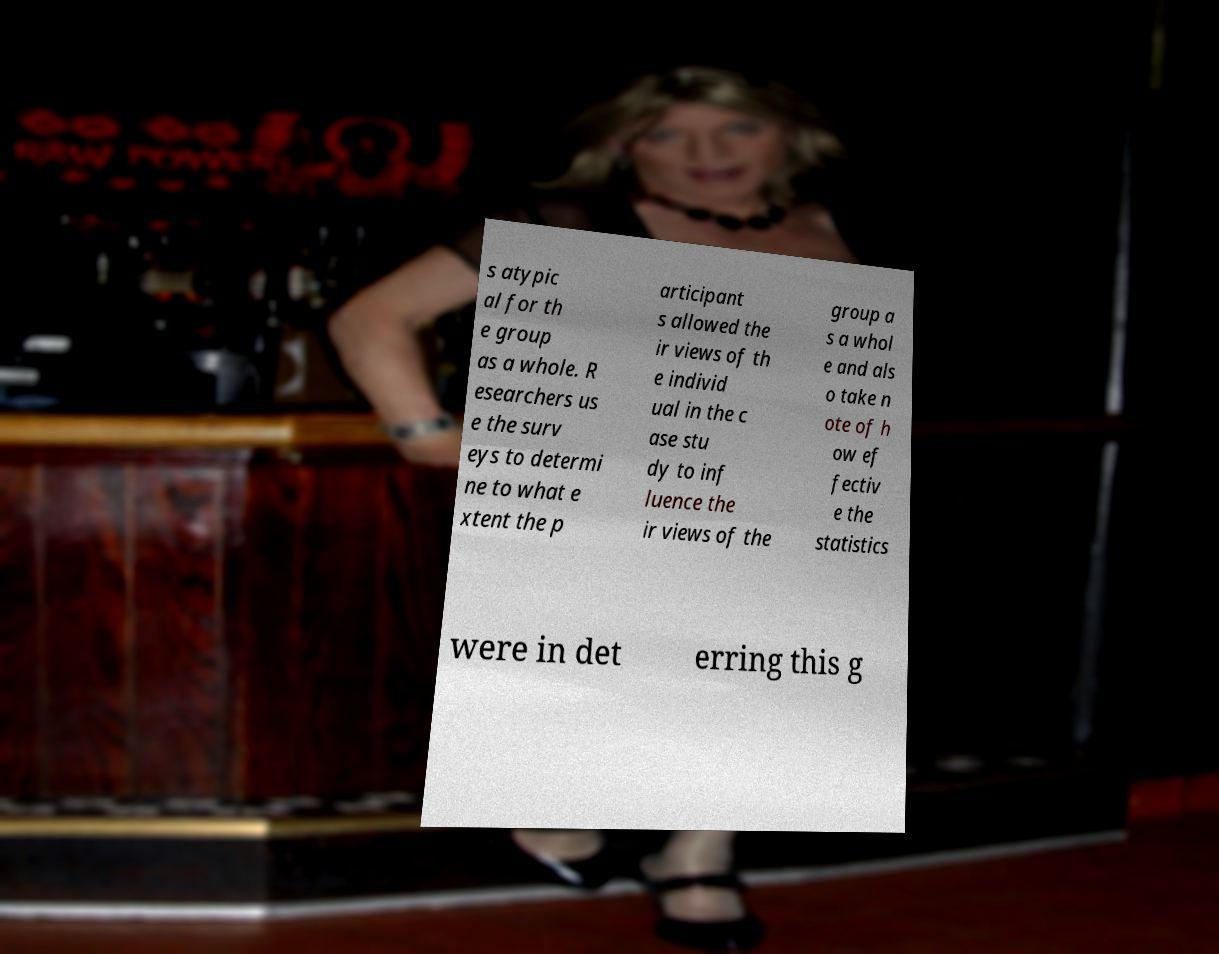For documentation purposes, I need the text within this image transcribed. Could you provide that? s atypic al for th e group as a whole. R esearchers us e the surv eys to determi ne to what e xtent the p articipant s allowed the ir views of th e individ ual in the c ase stu dy to inf luence the ir views of the group a s a whol e and als o take n ote of h ow ef fectiv e the statistics were in det erring this g 